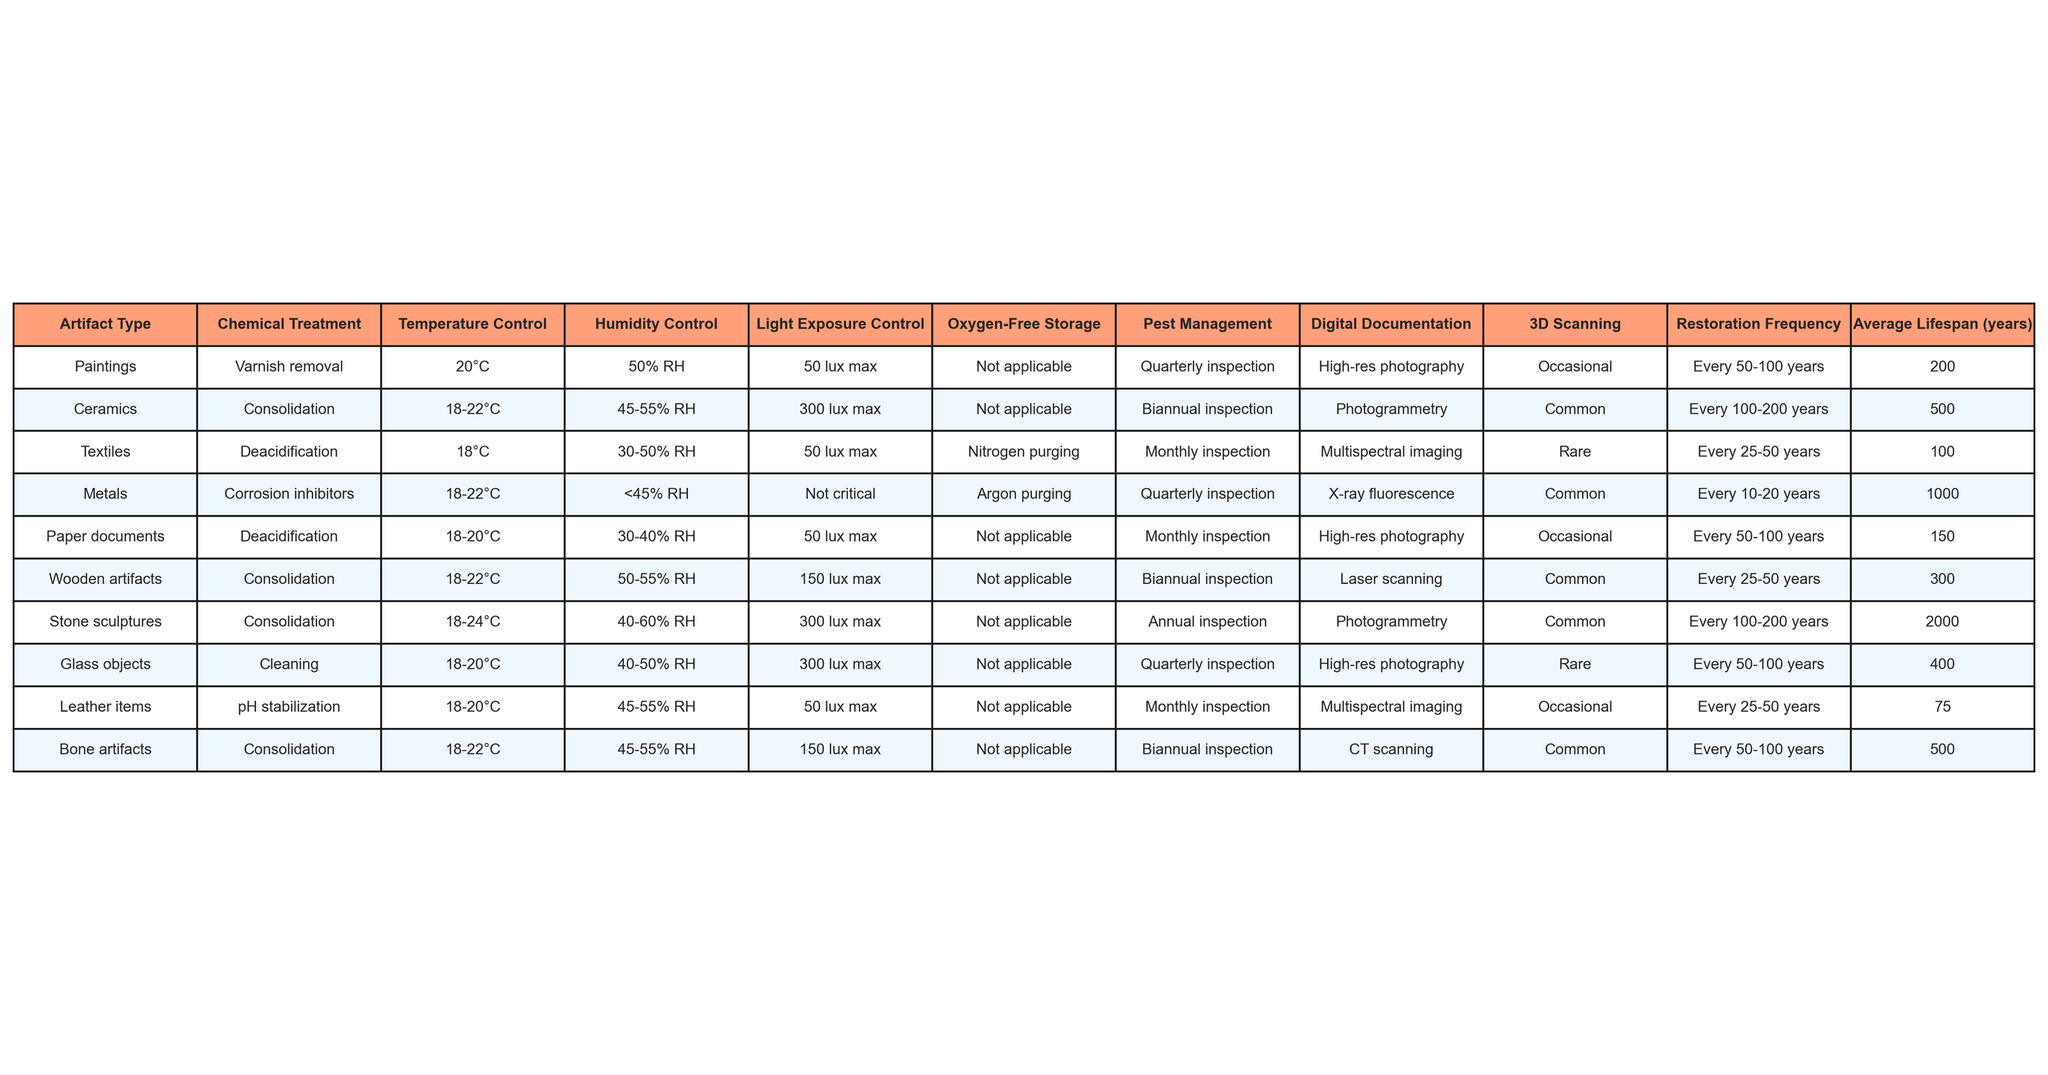What is the average lifespan of ceramics? To find the average lifespan of ceramics, we can refer to the table where ceramics are listed with an average lifespan of 500 years.
Answer: 500 years How often should metal artifacts be inspected? The table indicates that metal artifacts require quarterly inspections.
Answer: Quarterly Is oxygen-free storage used for wooden artifacts? The table shows that wooden artifacts do not use oxygen-free storage as it is marked "Not applicable".
Answer: No What is the maximum light exposure for textiles? The table states that textiles should have a maximum light exposure of 50 lux.
Answer: 50 lux What is the difference in average lifespan between bone artifacts and leather items? According to the table, bone artifacts have an average lifespan of 500 years, while leather items have 75 years. The difference is 500 - 75 = 425 years.
Answer: 425 years Are 3D scanning techniques commonly employed for ceramics? The table indicates that ceramics use photogrammetry, which is marked as "Common", but 3D scanning is not mentioned. Thus, 3D scanning is not commonly employed for ceramics.
Answer: No Which artifact type has the longest average lifespan? By examining the table, we see that stone sculptures have the longest average lifespan of 2000 years compared to the others.
Answer: Stone sculptures How many artifact types utilize multiphasic imaging for documentation? The table shows that out of the listed artifact types, only textiles and leather items use multispectral imaging for documentation, which totals to two artifact types.
Answer: 2 types What common preservation technique is used for paper documents? The preservation technique listed for paper documents is deacidification.
Answer: Deacidification What is the average lifespan of artifacts that undergo consolidation? The average lifespans for artifacts undergoing consolidation, specifically ceramics (500 years), wooden artifacts (300 years), stone sculptures (2000 years), and bone artifacts (500 years) can be averaged as (500 + 300 + 2000 + 500) / 4 = 575 years.
Answer: 575 years 